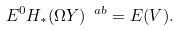<formula> <loc_0><loc_0><loc_500><loc_500>E ^ { 0 } H _ { * } ( \Omega Y ) ^ { \ a b } = E ( V ) .</formula> 